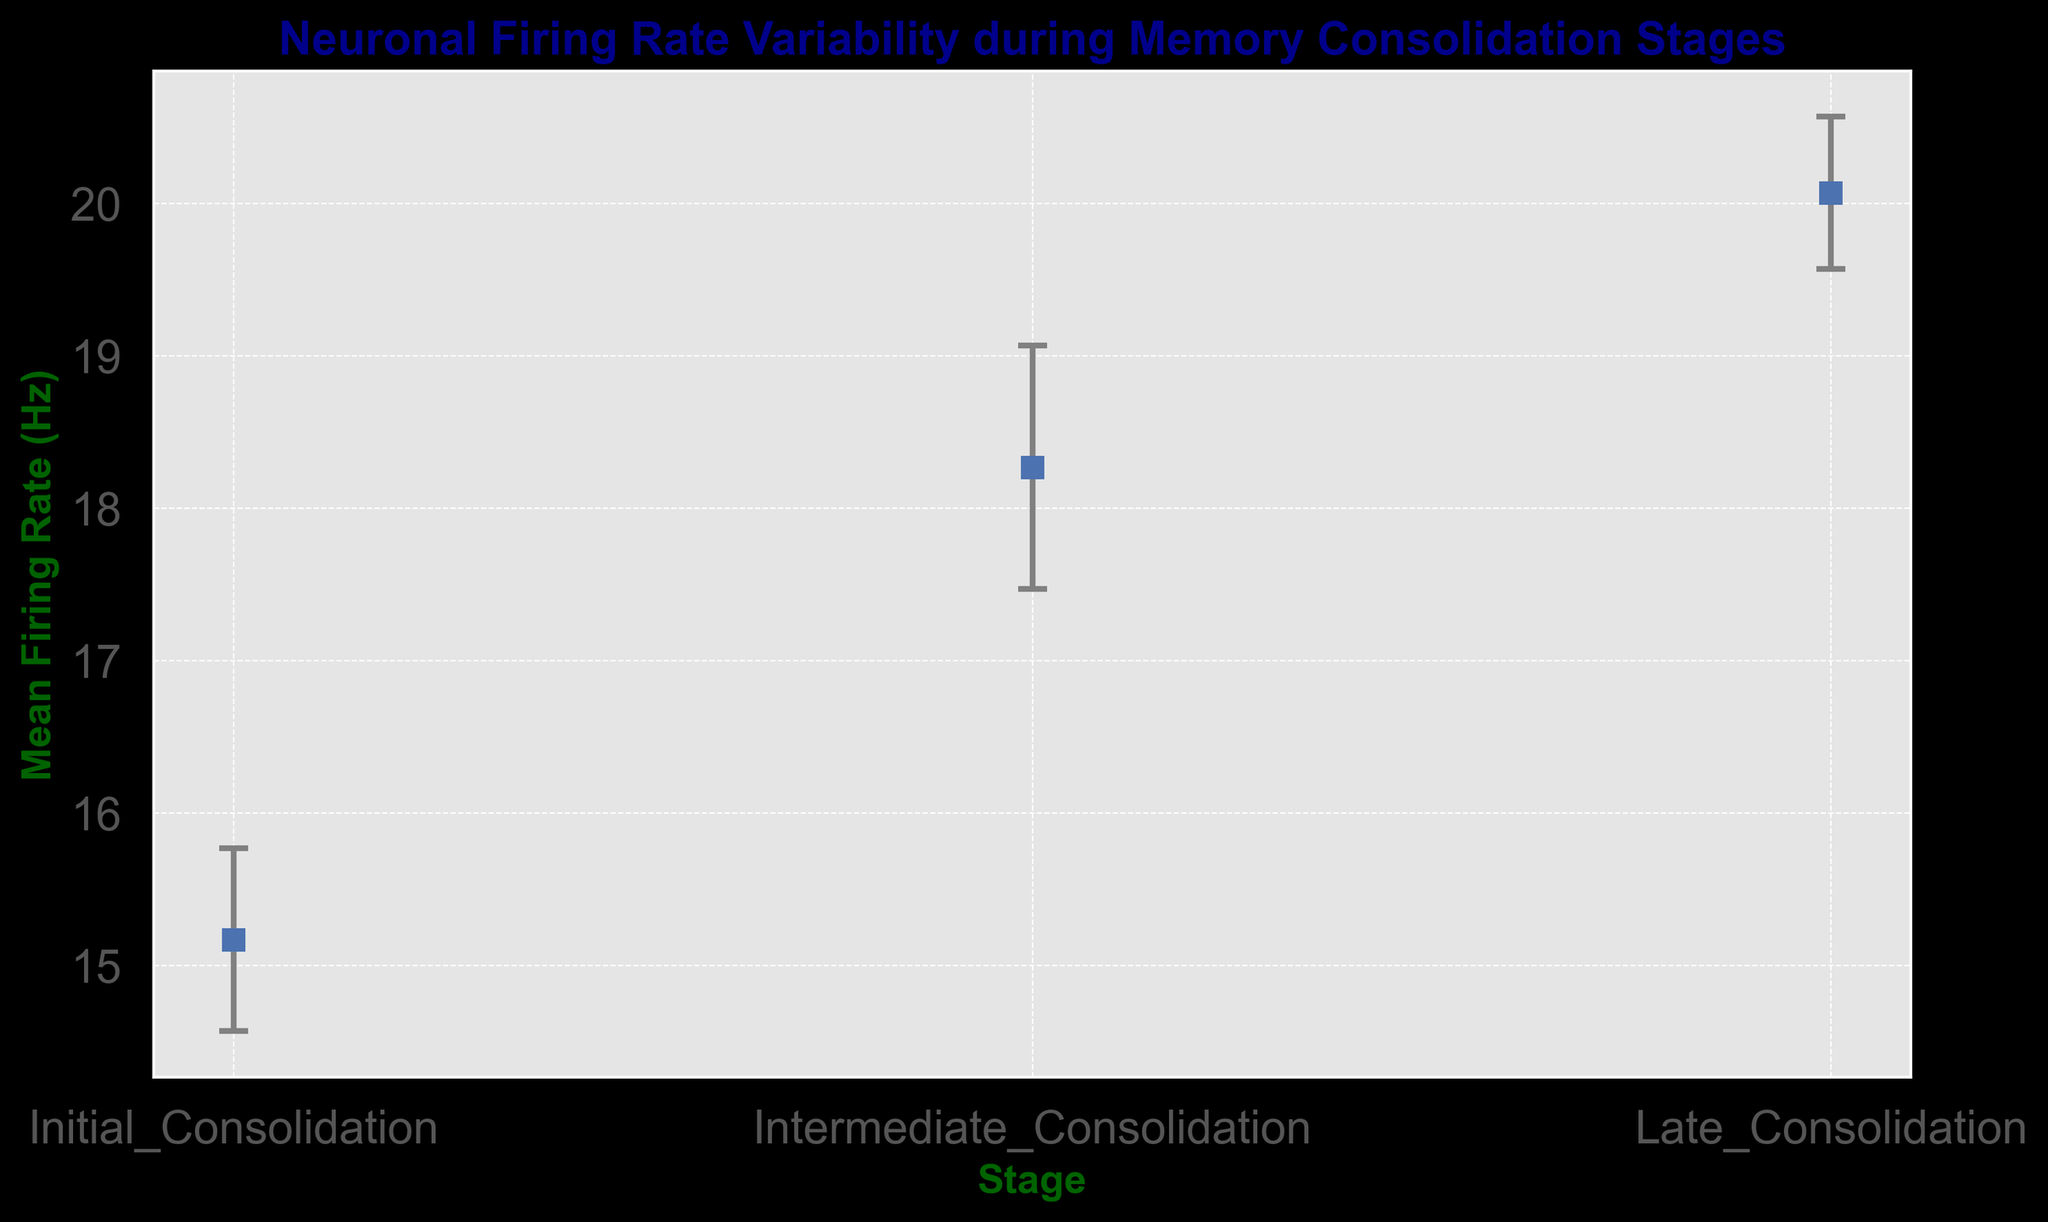What is the mean firing rate during the initial consolidation stage? To find the mean firing rate during the initial consolidation stage, refer to the data points corresponding to the "Initial_Consolidation" stage and calculate the average of the values.
Answer: 15.17 Hz How does the mean firing rate change from the initial to the intermediate consolidation stage? To determine the change in mean firing rate, subtract the mean firing rate of the initial consolidation stage from that of the intermediate consolidation stage.
Answer: Increase of 3.1 Hz Which stage has the highest mean firing rate? To find the stage with the highest mean firing rate, compare the means of all three stages ("Initial_Consolidation", "Intermediate_Consolidation", "Late_Consolidation").
Answer: Late Consolidation What is the difference in standard error between the initial and late consolidation stages? Subtract the standard error of the late consolidation stage from that of the initial consolidation stage.
Answer: 0.1 Compare the standard errors of all three stages and identify which stage has the highest standard error. Observe the y-error bars for each stage and determine which one is the longest (or has the highest mean standard error value).
Answer: Intermediate Consolidation What is the total of the mean firing rates for all three stages? Add the mean firing rates of all three stages together.
Answer: 53.3 Hz If the mean firing rate during the late consolidation stage is rounded to the nearest integer, what would it be? Round the mean firing rate of the late consolidation stage from decimal to the nearest whole number.
Answer: 20 Hz What is the relative change in mean firing rate from the intermediate to the late consolidation stage? Calculate the relative change by taking the difference of the means of intermediate and late consolidation stages, then divide by the mean of the intermediate consolidation stage. The formula is ((Mean Late - Mean Intermediate) / Mean Intermediate) * 100%.
Answer: 10.27% Between which stages is the largest increase in mean firing rate observed? Compare the differences in mean firing rates between subsequent stages: initial to intermediate, and intermediate to late. Find the largest increase.
Answer: Initial to Intermediate Consolidation 